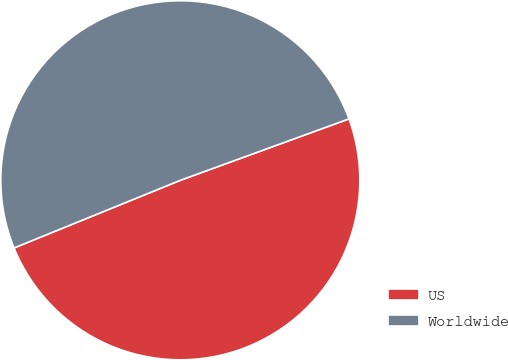<chart> <loc_0><loc_0><loc_500><loc_500><pie_chart><fcel>US<fcel>Worldwide<nl><fcel>49.41%<fcel>50.59%<nl></chart> 